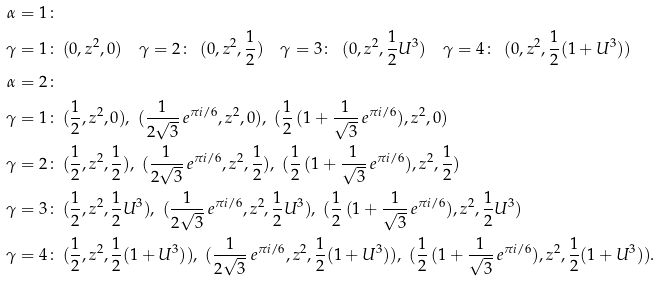<formula> <loc_0><loc_0><loc_500><loc_500>\alpha = 1 \colon \, & \\ \gamma = 1 \colon \, & ( 0 , z ^ { 2 } , 0 ) \quad \gamma = 2 \colon \, \ ( 0 , z ^ { 2 } , \frac { 1 } { 2 } ) \quad \gamma = 3 \colon \, \ ( 0 , z ^ { 2 } , \frac { 1 } { 2 } U ^ { 3 } ) \quad \gamma = 4 \colon \, \ ( 0 , z ^ { 2 } , \frac { 1 } { 2 } ( 1 + U ^ { 3 } ) ) \\ \alpha = 2 \colon \, & \\ \gamma = 1 \colon \, & ( \frac { 1 } { 2 } , z ^ { 2 } , 0 ) , \ ( \frac { 1 } { 2 \sqrt { 3 } } \, e ^ { \pi i / 6 } , z ^ { 2 } , 0 ) , \ ( \frac { 1 } { 2 } \, ( 1 + \frac { 1 } { \sqrt { 3 } } \, e ^ { \pi i / 6 } ) , z ^ { 2 } , 0 ) \\ \gamma = 2 \colon \, & ( \frac { 1 } { 2 } , z ^ { 2 } , \frac { 1 } { 2 } ) , \ ( \frac { 1 } { 2 \sqrt { 3 } } \, e ^ { \pi i / 6 } , z ^ { 2 } , \frac { 1 } { 2 } ) , \ ( \frac { 1 } { 2 } \, ( 1 + \frac { 1 } { \sqrt { 3 } } \, e ^ { \pi i / 6 } ) , z ^ { 2 } , \frac { 1 } { 2 } ) \\ \gamma = 3 \colon \, & ( \frac { 1 } { 2 } , z ^ { 2 } , \frac { 1 } { 2 } U ^ { 3 } ) , \ ( \frac { 1 } { 2 \sqrt { 3 } } \, e ^ { \pi i / 6 } , z ^ { 2 } , \frac { 1 } { 2 } U ^ { 3 } ) , \ ( \frac { 1 } { 2 } \, ( 1 + \frac { 1 } { \sqrt { 3 } } \, e ^ { \pi i / 6 } ) , z ^ { 2 } , \frac { 1 } { 2 } U ^ { 3 } ) \\ \gamma = 4 \colon \, & ( \frac { 1 } { 2 } , z ^ { 2 } , \frac { 1 } { 2 } ( 1 + U ^ { 3 } ) ) , \ ( \frac { 1 } { 2 \sqrt { 3 } } \, e ^ { \pi i / 6 } , z ^ { 2 } , \frac { 1 } { 2 } ( 1 + U ^ { 3 } ) ) , \ ( \frac { 1 } { 2 } \, ( 1 + \frac { 1 } { \sqrt { 3 } } \, e ^ { \pi i / 6 } ) , z ^ { 2 } , \frac { 1 } { 2 } ( 1 + U ^ { 3 } ) ) .</formula> 